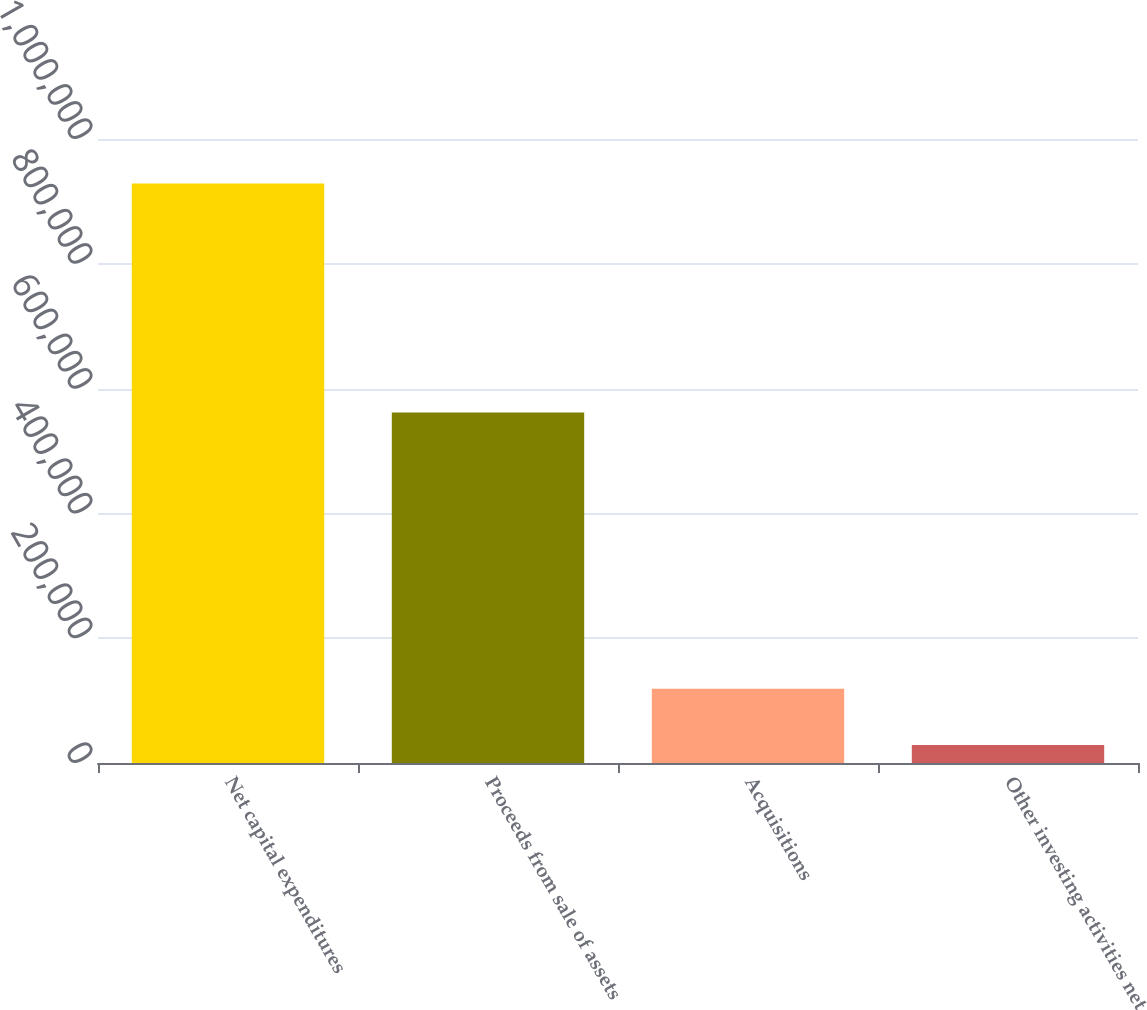Convert chart. <chart><loc_0><loc_0><loc_500><loc_500><bar_chart><fcel>Net capital expenditures<fcel>Proceeds from sale of assets<fcel>Acquisitions<fcel>Other investing activities net<nl><fcel>928574<fcel>561739<fcel>118992<fcel>29039<nl></chart> 